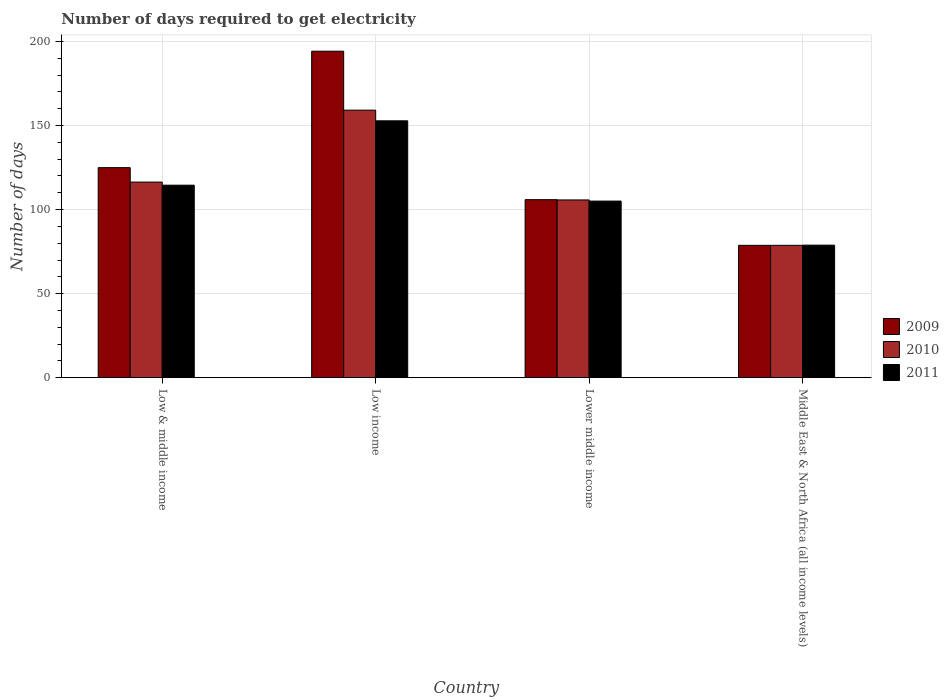How many different coloured bars are there?
Your answer should be compact. 3. Are the number of bars on each tick of the X-axis equal?
Your response must be concise. Yes. How many bars are there on the 1st tick from the left?
Your answer should be compact. 3. How many bars are there on the 3rd tick from the right?
Your answer should be very brief. 3. What is the label of the 2nd group of bars from the left?
Your answer should be compact. Low income. What is the number of days required to get electricity in in 2010 in Low income?
Ensure brevity in your answer.  159.18. Across all countries, what is the maximum number of days required to get electricity in in 2009?
Your answer should be compact. 194.25. Across all countries, what is the minimum number of days required to get electricity in in 2011?
Your response must be concise. 78.85. In which country was the number of days required to get electricity in in 2009 minimum?
Ensure brevity in your answer.  Middle East & North Africa (all income levels). What is the total number of days required to get electricity in in 2010 in the graph?
Make the answer very short. 460.04. What is the difference between the number of days required to get electricity in in 2010 in Low & middle income and that in Low income?
Keep it short and to the point. -42.81. What is the difference between the number of days required to get electricity in in 2011 in Middle East & North Africa (all income levels) and the number of days required to get electricity in in 2009 in Low & middle income?
Your response must be concise. -46.11. What is the average number of days required to get electricity in in 2009 per country?
Your answer should be compact. 125.96. What is the difference between the number of days required to get electricity in of/in 2011 and number of days required to get electricity in of/in 2010 in Lower middle income?
Your response must be concise. -0.69. In how many countries, is the number of days required to get electricity in in 2010 greater than 130 days?
Your answer should be very brief. 1. What is the ratio of the number of days required to get electricity in in 2009 in Low income to that in Lower middle income?
Ensure brevity in your answer.  1.83. Is the difference between the number of days required to get electricity in in 2011 in Low income and Lower middle income greater than the difference between the number of days required to get electricity in in 2010 in Low income and Lower middle income?
Provide a short and direct response. No. What is the difference between the highest and the second highest number of days required to get electricity in in 2010?
Provide a succinct answer. -10.62. What is the difference between the highest and the lowest number of days required to get electricity in in 2011?
Provide a short and direct response. 73.97. How many bars are there?
Your answer should be compact. 12. How many countries are there in the graph?
Your answer should be very brief. 4. What is the difference between two consecutive major ticks on the Y-axis?
Your response must be concise. 50. Does the graph contain any zero values?
Make the answer very short. No. How are the legend labels stacked?
Offer a very short reply. Vertical. What is the title of the graph?
Give a very brief answer. Number of days required to get electricity. Does "1964" appear as one of the legend labels in the graph?
Ensure brevity in your answer.  No. What is the label or title of the Y-axis?
Give a very brief answer. Number of days. What is the Number of days of 2009 in Low & middle income?
Ensure brevity in your answer.  124.96. What is the Number of days of 2010 in Low & middle income?
Provide a succinct answer. 116.37. What is the Number of days of 2011 in Low & middle income?
Give a very brief answer. 114.53. What is the Number of days of 2009 in Low income?
Make the answer very short. 194.25. What is the Number of days in 2010 in Low income?
Your answer should be very brief. 159.18. What is the Number of days in 2011 in Low income?
Provide a succinct answer. 152.82. What is the Number of days in 2009 in Lower middle income?
Provide a succinct answer. 105.91. What is the Number of days of 2010 in Lower middle income?
Provide a short and direct response. 105.76. What is the Number of days in 2011 in Lower middle income?
Keep it short and to the point. 105.07. What is the Number of days in 2009 in Middle East & North Africa (all income levels)?
Your answer should be very brief. 78.74. What is the Number of days of 2010 in Middle East & North Africa (all income levels)?
Offer a very short reply. 78.74. What is the Number of days in 2011 in Middle East & North Africa (all income levels)?
Give a very brief answer. 78.85. Across all countries, what is the maximum Number of days in 2009?
Give a very brief answer. 194.25. Across all countries, what is the maximum Number of days in 2010?
Keep it short and to the point. 159.18. Across all countries, what is the maximum Number of days of 2011?
Ensure brevity in your answer.  152.82. Across all countries, what is the minimum Number of days of 2009?
Make the answer very short. 78.74. Across all countries, what is the minimum Number of days in 2010?
Your answer should be very brief. 78.74. Across all countries, what is the minimum Number of days of 2011?
Ensure brevity in your answer.  78.85. What is the total Number of days in 2009 in the graph?
Offer a terse response. 503.86. What is the total Number of days of 2010 in the graph?
Provide a succinct answer. 460.04. What is the total Number of days in 2011 in the graph?
Your response must be concise. 451.27. What is the difference between the Number of days of 2009 in Low & middle income and that in Low income?
Your answer should be compact. -69.29. What is the difference between the Number of days of 2010 in Low & middle income and that in Low income?
Offer a terse response. -42.81. What is the difference between the Number of days of 2011 in Low & middle income and that in Low income?
Provide a short and direct response. -38.29. What is the difference between the Number of days in 2009 in Low & middle income and that in Lower middle income?
Your response must be concise. 19.05. What is the difference between the Number of days in 2010 in Low & middle income and that in Lower middle income?
Offer a terse response. 10.62. What is the difference between the Number of days in 2011 in Low & middle income and that in Lower middle income?
Offer a very short reply. 9.47. What is the difference between the Number of days in 2009 in Low & middle income and that in Middle East & North Africa (all income levels)?
Keep it short and to the point. 46.22. What is the difference between the Number of days in 2010 in Low & middle income and that in Middle East & North Africa (all income levels)?
Provide a succinct answer. 37.64. What is the difference between the Number of days of 2011 in Low & middle income and that in Middle East & North Africa (all income levels)?
Keep it short and to the point. 35.68. What is the difference between the Number of days of 2009 in Low income and that in Lower middle income?
Offer a very short reply. 88.34. What is the difference between the Number of days of 2010 in Low income and that in Lower middle income?
Keep it short and to the point. 53.42. What is the difference between the Number of days of 2011 in Low income and that in Lower middle income?
Keep it short and to the point. 47.75. What is the difference between the Number of days of 2009 in Low income and that in Middle East & North Africa (all income levels)?
Offer a very short reply. 115.51. What is the difference between the Number of days in 2010 in Low income and that in Middle East & North Africa (all income levels)?
Your answer should be compact. 80.44. What is the difference between the Number of days in 2011 in Low income and that in Middle East & North Africa (all income levels)?
Provide a short and direct response. 73.97. What is the difference between the Number of days of 2009 in Lower middle income and that in Middle East & North Africa (all income levels)?
Your answer should be compact. 27.17. What is the difference between the Number of days in 2010 in Lower middle income and that in Middle East & North Africa (all income levels)?
Your answer should be compact. 27.02. What is the difference between the Number of days in 2011 in Lower middle income and that in Middle East & North Africa (all income levels)?
Your answer should be compact. 26.22. What is the difference between the Number of days of 2009 in Low & middle income and the Number of days of 2010 in Low income?
Your response must be concise. -34.22. What is the difference between the Number of days of 2009 in Low & middle income and the Number of days of 2011 in Low income?
Offer a very short reply. -27.86. What is the difference between the Number of days of 2010 in Low & middle income and the Number of days of 2011 in Low income?
Give a very brief answer. -36.45. What is the difference between the Number of days of 2009 in Low & middle income and the Number of days of 2010 in Lower middle income?
Provide a short and direct response. 19.2. What is the difference between the Number of days of 2009 in Low & middle income and the Number of days of 2011 in Lower middle income?
Your response must be concise. 19.89. What is the difference between the Number of days of 2010 in Low & middle income and the Number of days of 2011 in Lower middle income?
Ensure brevity in your answer.  11.31. What is the difference between the Number of days in 2009 in Low & middle income and the Number of days in 2010 in Middle East & North Africa (all income levels)?
Your answer should be very brief. 46.22. What is the difference between the Number of days of 2009 in Low & middle income and the Number of days of 2011 in Middle East & North Africa (all income levels)?
Keep it short and to the point. 46.11. What is the difference between the Number of days of 2010 in Low & middle income and the Number of days of 2011 in Middle East & North Africa (all income levels)?
Your response must be concise. 37.52. What is the difference between the Number of days in 2009 in Low income and the Number of days in 2010 in Lower middle income?
Your response must be concise. 88.49. What is the difference between the Number of days of 2009 in Low income and the Number of days of 2011 in Lower middle income?
Your answer should be very brief. 89.18. What is the difference between the Number of days in 2010 in Low income and the Number of days in 2011 in Lower middle income?
Ensure brevity in your answer.  54.11. What is the difference between the Number of days of 2009 in Low income and the Number of days of 2010 in Middle East & North Africa (all income levels)?
Give a very brief answer. 115.51. What is the difference between the Number of days in 2009 in Low income and the Number of days in 2011 in Middle East & North Africa (all income levels)?
Your answer should be compact. 115.4. What is the difference between the Number of days in 2010 in Low income and the Number of days in 2011 in Middle East & North Africa (all income levels)?
Your response must be concise. 80.33. What is the difference between the Number of days in 2009 in Lower middle income and the Number of days in 2010 in Middle East & North Africa (all income levels)?
Your answer should be very brief. 27.17. What is the difference between the Number of days of 2009 in Lower middle income and the Number of days of 2011 in Middle East & North Africa (all income levels)?
Your answer should be compact. 27.06. What is the difference between the Number of days in 2010 in Lower middle income and the Number of days in 2011 in Middle East & North Africa (all income levels)?
Your response must be concise. 26.91. What is the average Number of days of 2009 per country?
Provide a short and direct response. 125.96. What is the average Number of days in 2010 per country?
Your answer should be compact. 115.01. What is the average Number of days in 2011 per country?
Give a very brief answer. 112.82. What is the difference between the Number of days in 2009 and Number of days in 2010 in Low & middle income?
Your answer should be compact. 8.58. What is the difference between the Number of days in 2009 and Number of days in 2011 in Low & middle income?
Provide a succinct answer. 10.42. What is the difference between the Number of days in 2010 and Number of days in 2011 in Low & middle income?
Offer a terse response. 1.84. What is the difference between the Number of days of 2009 and Number of days of 2010 in Low income?
Your answer should be compact. 35.07. What is the difference between the Number of days in 2009 and Number of days in 2011 in Low income?
Offer a terse response. 41.43. What is the difference between the Number of days in 2010 and Number of days in 2011 in Low income?
Give a very brief answer. 6.36. What is the difference between the Number of days of 2009 and Number of days of 2010 in Lower middle income?
Your answer should be very brief. 0.16. What is the difference between the Number of days in 2009 and Number of days in 2011 in Lower middle income?
Give a very brief answer. 0.84. What is the difference between the Number of days of 2010 and Number of days of 2011 in Lower middle income?
Make the answer very short. 0.69. What is the difference between the Number of days in 2009 and Number of days in 2011 in Middle East & North Africa (all income levels)?
Your response must be concise. -0.11. What is the difference between the Number of days in 2010 and Number of days in 2011 in Middle East & North Africa (all income levels)?
Your response must be concise. -0.11. What is the ratio of the Number of days in 2009 in Low & middle income to that in Low income?
Your answer should be very brief. 0.64. What is the ratio of the Number of days in 2010 in Low & middle income to that in Low income?
Give a very brief answer. 0.73. What is the ratio of the Number of days of 2011 in Low & middle income to that in Low income?
Make the answer very short. 0.75. What is the ratio of the Number of days in 2009 in Low & middle income to that in Lower middle income?
Your answer should be compact. 1.18. What is the ratio of the Number of days in 2010 in Low & middle income to that in Lower middle income?
Your response must be concise. 1.1. What is the ratio of the Number of days of 2011 in Low & middle income to that in Lower middle income?
Your answer should be very brief. 1.09. What is the ratio of the Number of days of 2009 in Low & middle income to that in Middle East & North Africa (all income levels)?
Give a very brief answer. 1.59. What is the ratio of the Number of days in 2010 in Low & middle income to that in Middle East & North Africa (all income levels)?
Your answer should be very brief. 1.48. What is the ratio of the Number of days of 2011 in Low & middle income to that in Middle East & North Africa (all income levels)?
Your answer should be compact. 1.45. What is the ratio of the Number of days in 2009 in Low income to that in Lower middle income?
Your response must be concise. 1.83. What is the ratio of the Number of days in 2010 in Low income to that in Lower middle income?
Provide a succinct answer. 1.51. What is the ratio of the Number of days of 2011 in Low income to that in Lower middle income?
Your answer should be compact. 1.45. What is the ratio of the Number of days in 2009 in Low income to that in Middle East & North Africa (all income levels)?
Make the answer very short. 2.47. What is the ratio of the Number of days in 2010 in Low income to that in Middle East & North Africa (all income levels)?
Ensure brevity in your answer.  2.02. What is the ratio of the Number of days in 2011 in Low income to that in Middle East & North Africa (all income levels)?
Make the answer very short. 1.94. What is the ratio of the Number of days of 2009 in Lower middle income to that in Middle East & North Africa (all income levels)?
Keep it short and to the point. 1.35. What is the ratio of the Number of days in 2010 in Lower middle income to that in Middle East & North Africa (all income levels)?
Keep it short and to the point. 1.34. What is the ratio of the Number of days of 2011 in Lower middle income to that in Middle East & North Africa (all income levels)?
Ensure brevity in your answer.  1.33. What is the difference between the highest and the second highest Number of days of 2009?
Your answer should be compact. 69.29. What is the difference between the highest and the second highest Number of days of 2010?
Make the answer very short. 42.81. What is the difference between the highest and the second highest Number of days in 2011?
Your answer should be very brief. 38.29. What is the difference between the highest and the lowest Number of days of 2009?
Offer a terse response. 115.51. What is the difference between the highest and the lowest Number of days in 2010?
Provide a succinct answer. 80.44. What is the difference between the highest and the lowest Number of days of 2011?
Provide a short and direct response. 73.97. 